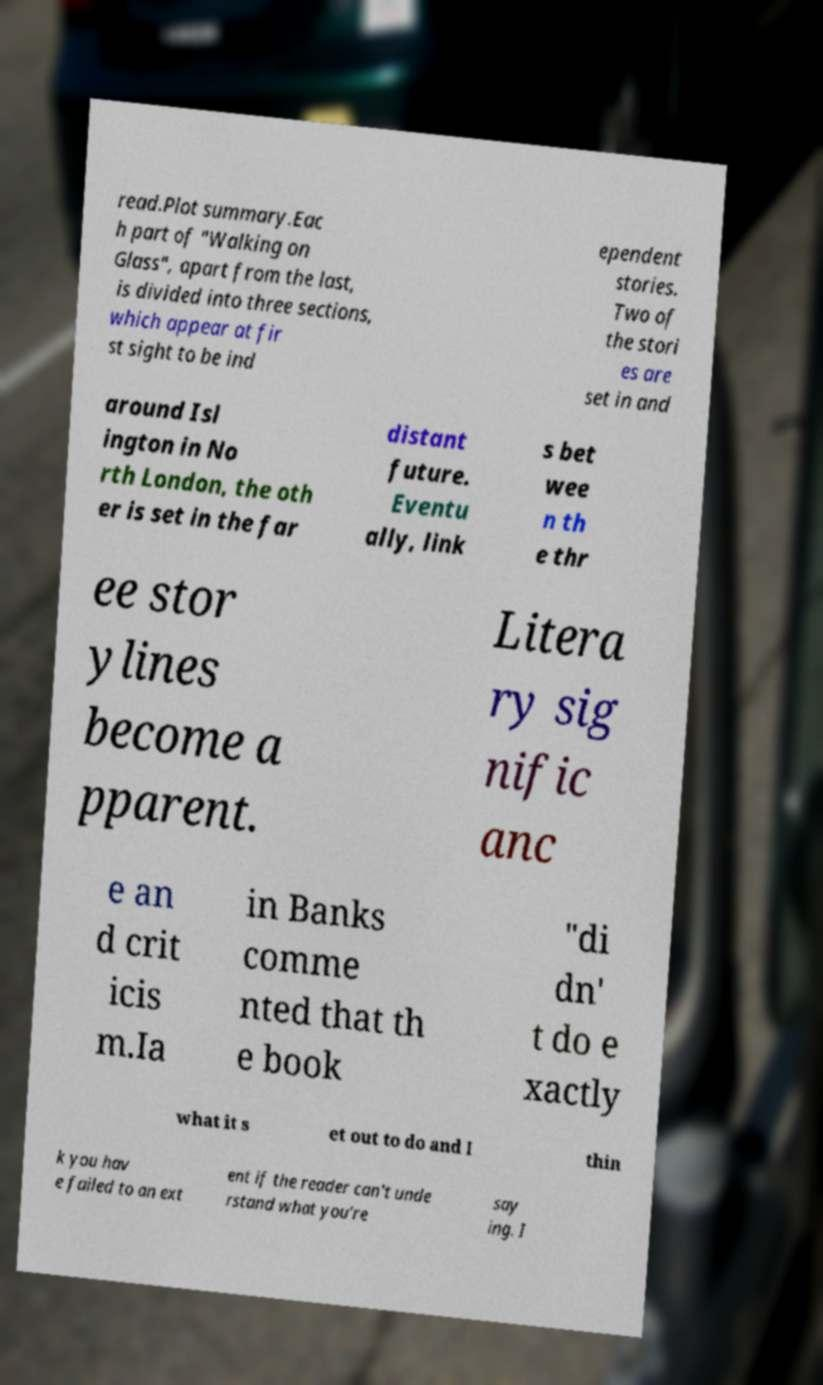Could you assist in decoding the text presented in this image and type it out clearly? read.Plot summary.Eac h part of "Walking on Glass", apart from the last, is divided into three sections, which appear at fir st sight to be ind ependent stories. Two of the stori es are set in and around Isl ington in No rth London, the oth er is set in the far distant future. Eventu ally, link s bet wee n th e thr ee stor ylines become a pparent. Litera ry sig nific anc e an d crit icis m.Ia in Banks comme nted that th e book "di dn' t do e xactly what it s et out to do and I thin k you hav e failed to an ext ent if the reader can't unde rstand what you're say ing. I 